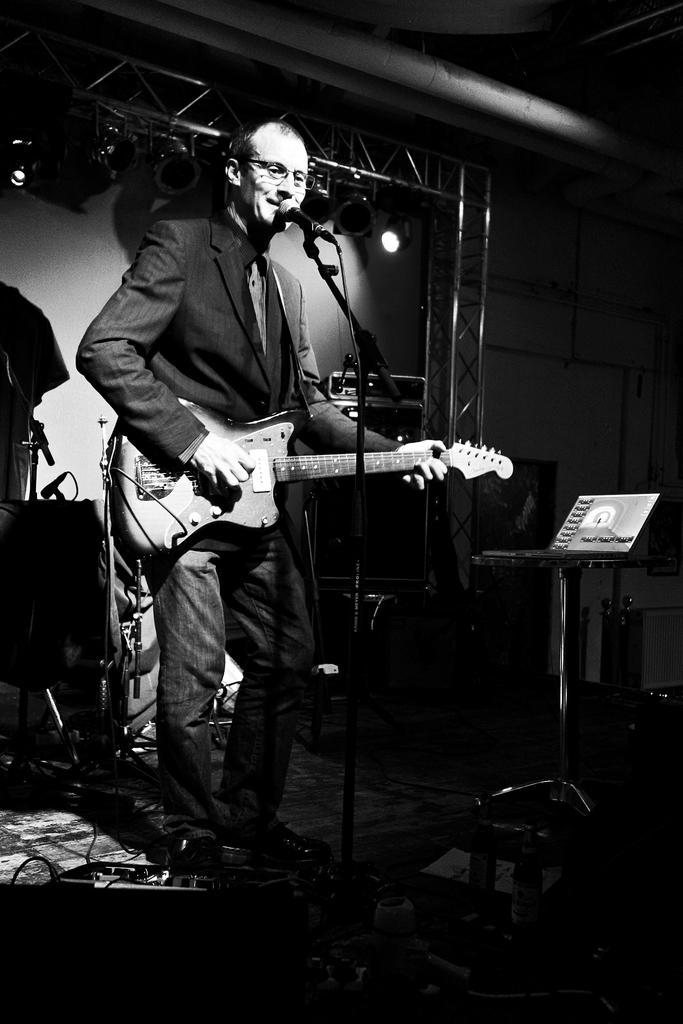In one or two sentences, can you explain what this image depicts? In this image, there is a person wearing clothes and playing a guitar. This person is standing in front of the mic. There are some musical equipment behind this person. There are some lights in the top left of the image. There is a table on the right side of the image. 